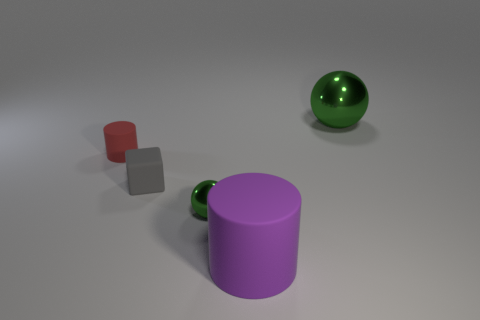What size is the green metal thing that is behind the red rubber object behind the gray matte cube?
Make the answer very short. Large. Are there the same number of tiny green metallic objects that are behind the red matte cylinder and big purple matte things that are behind the large purple cylinder?
Make the answer very short. Yes. Is there a small red matte object in front of the rubber object that is in front of the matte cube?
Ensure brevity in your answer.  No. There is a small thing that is made of the same material as the small gray cube; what shape is it?
Make the answer very short. Cylinder. Is there any other thing that is the same color as the tiny rubber cylinder?
Keep it short and to the point. No. What material is the cylinder in front of the cylinder on the left side of the big cylinder?
Provide a succinct answer. Rubber. Is there another small metal object of the same shape as the tiny green metallic thing?
Your answer should be very brief. No. How many other objects are there of the same shape as the small red object?
Your answer should be very brief. 1. There is a object that is right of the gray thing and on the left side of the big purple object; what is its shape?
Offer a terse response. Sphere. There is a metal thing that is left of the large green shiny sphere; how big is it?
Offer a very short reply. Small. 